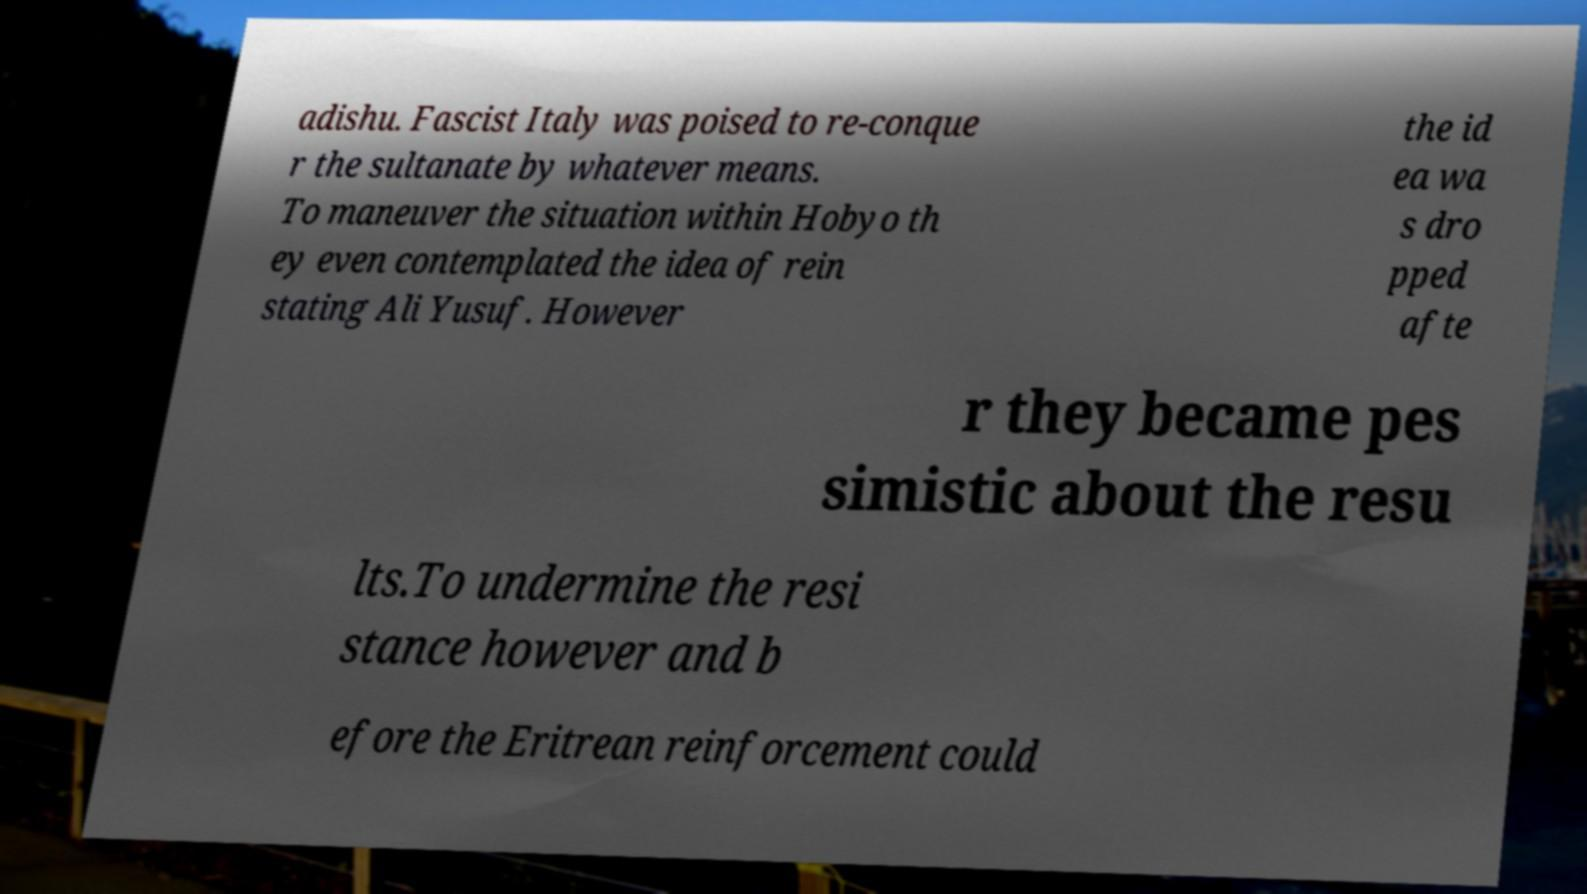What messages or text are displayed in this image? I need them in a readable, typed format. adishu. Fascist Italy was poised to re-conque r the sultanate by whatever means. To maneuver the situation within Hobyo th ey even contemplated the idea of rein stating Ali Yusuf. However the id ea wa s dro pped afte r they became pes simistic about the resu lts.To undermine the resi stance however and b efore the Eritrean reinforcement could 